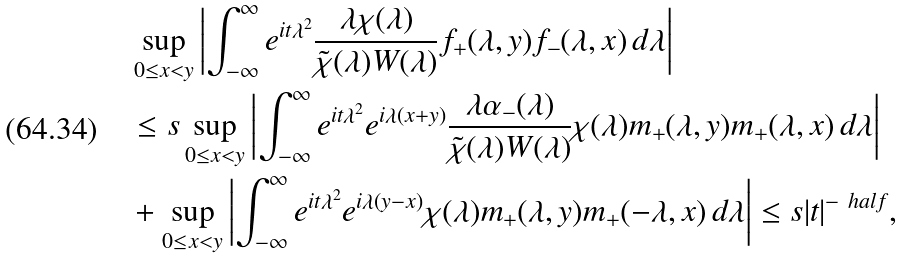Convert formula to latex. <formula><loc_0><loc_0><loc_500><loc_500>& \sup _ { 0 \leq x < y } \left | \int _ { - \infty } ^ { \infty } e ^ { i t \lambda ^ { 2 } } \frac { \lambda \chi ( \lambda ) } { \tilde { \chi } ( \lambda ) W ( \lambda ) } f _ { + } ( \lambda , y ) f _ { - } ( \lambda , x ) \, d \lambda \right | \\ & \leq s \sup _ { 0 \leq x < y } \left | \int _ { - \infty } ^ { \infty } e ^ { i t \lambda ^ { 2 } } e ^ { i \lambda ( x + y ) } \frac { \lambda \alpha _ { - } ( \lambda ) } { \tilde { \chi } ( \lambda ) W ( \lambda ) } \chi ( \lambda ) m _ { + } ( \lambda , y ) m _ { + } ( \lambda , x ) \, d \lambda \right | \\ & + \sup _ { 0 \leq x < y } \left | \int _ { - \infty } ^ { \infty } e ^ { i t \lambda ^ { 2 } } e ^ { i \lambda ( y - x ) } \chi ( \lambda ) m _ { + } ( \lambda , y ) m _ { + } ( - \lambda , x ) \, d \lambda \right | \leq s | t | ^ { - \ h a l f } ,</formula> 